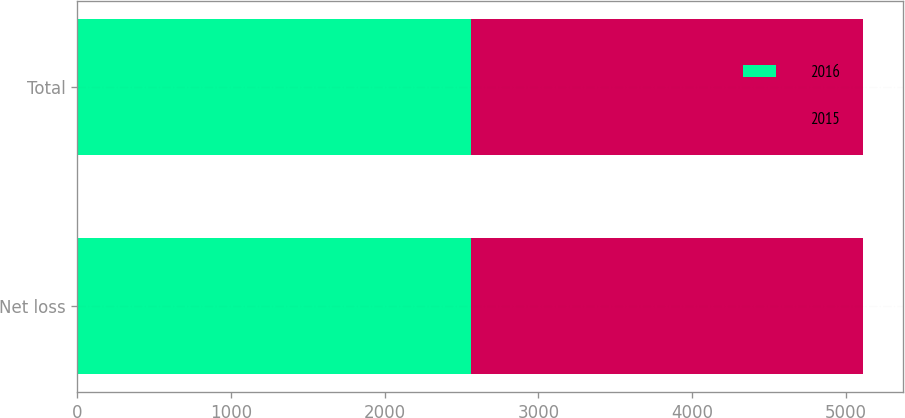Convert chart. <chart><loc_0><loc_0><loc_500><loc_500><stacked_bar_chart><ecel><fcel>Net loss<fcel>Total<nl><fcel>2016<fcel>2563<fcel>2563<nl><fcel>2015<fcel>2553<fcel>2553<nl></chart> 